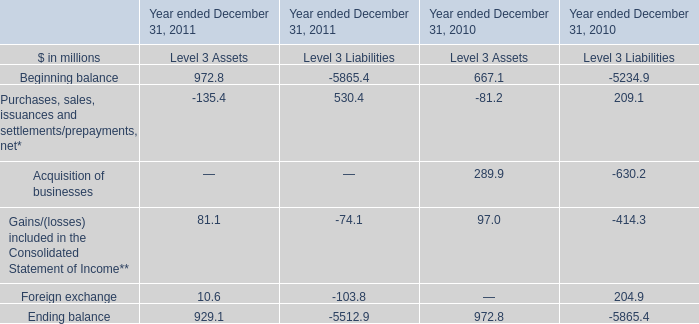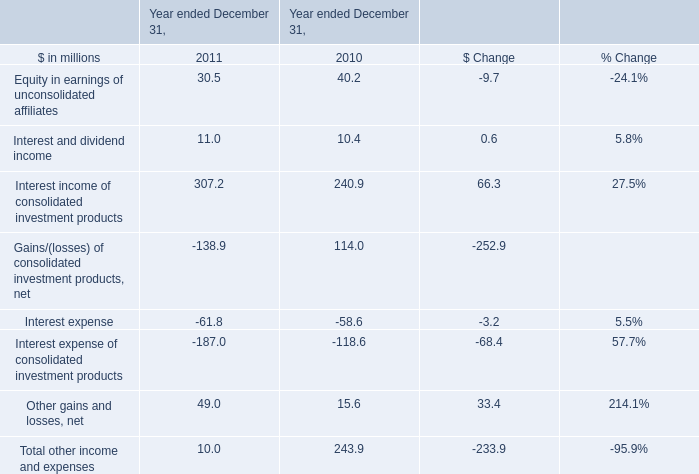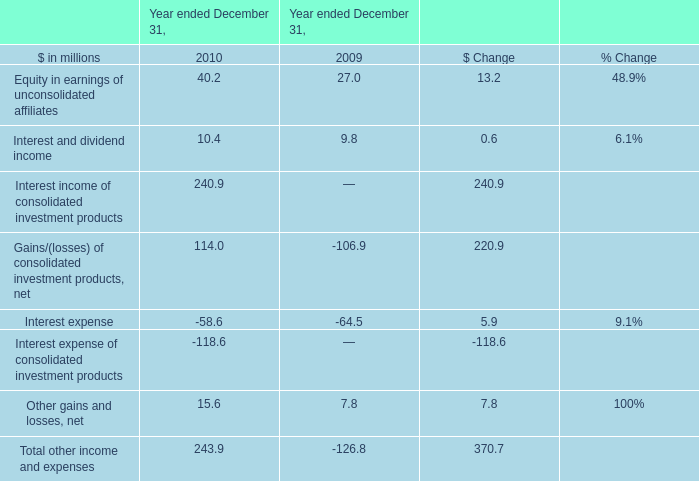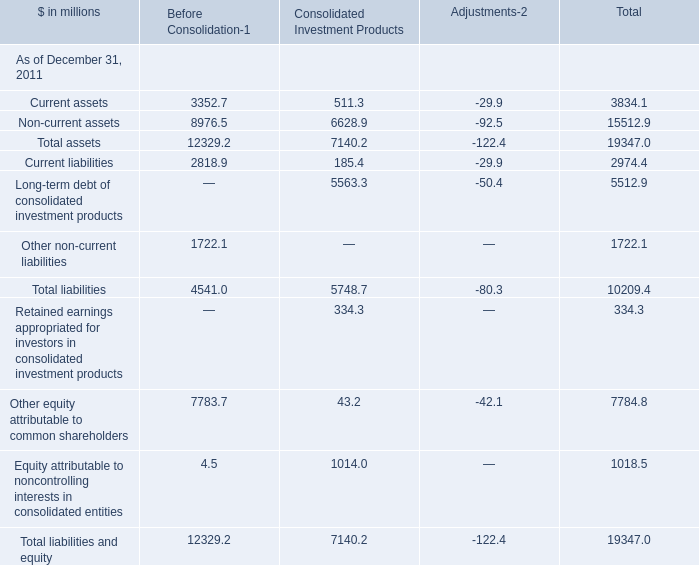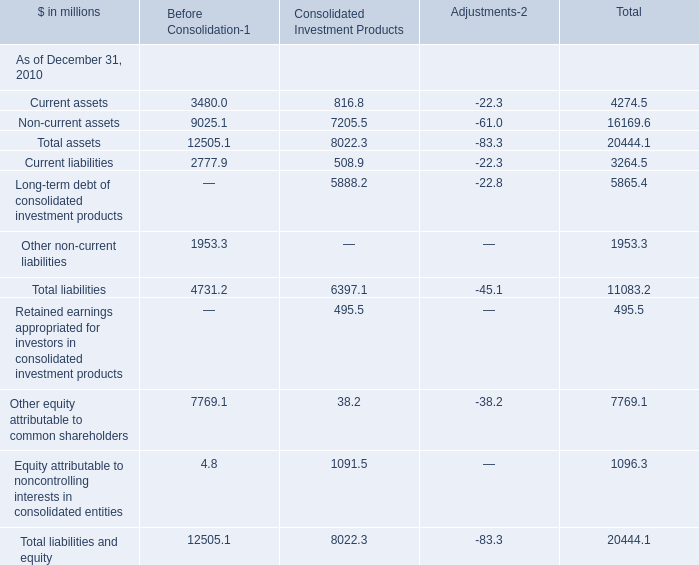What is the ratio of all Before Consolidation that are smaller than 2000 to the sum of Before Consolidation, in 2010? 
Computations: ((1953.3 + 4.8) / ((12505.1 + 4731.2) + 12505.1))
Answer: 0.06584. 